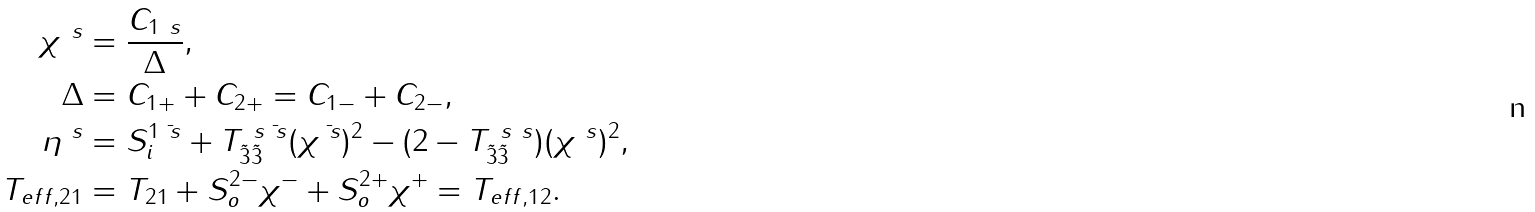Convert formula to latex. <formula><loc_0><loc_0><loc_500><loc_500>\chi ^ { \ s } & = \frac { C _ { 1 \ s } } { \Delta } , \\ \Delta & = C _ { 1 + } + C _ { 2 + } = C _ { 1 - } + C _ { 2 - } , \\ \eta ^ { \ s } & = S _ { i } ^ { 1 \bar { \ s } } + T _ { \tilde { 3 } \tilde { 3 } } ^ { \ s \bar { \ s } } ( \chi ^ { \bar { \ s } } ) ^ { 2 } - ( 2 - T _ { \tilde { 3 } \tilde { 3 } } ^ { \ s \ s } ) ( \chi ^ { \ s } ) ^ { 2 } , \\ T _ { e f f , 2 1 } & = T _ { 2 1 } + S _ { o } ^ { 2 - } \chi ^ { - } + S _ { o } ^ { 2 + } \chi ^ { + } = T _ { e f f , 1 2 } .</formula> 